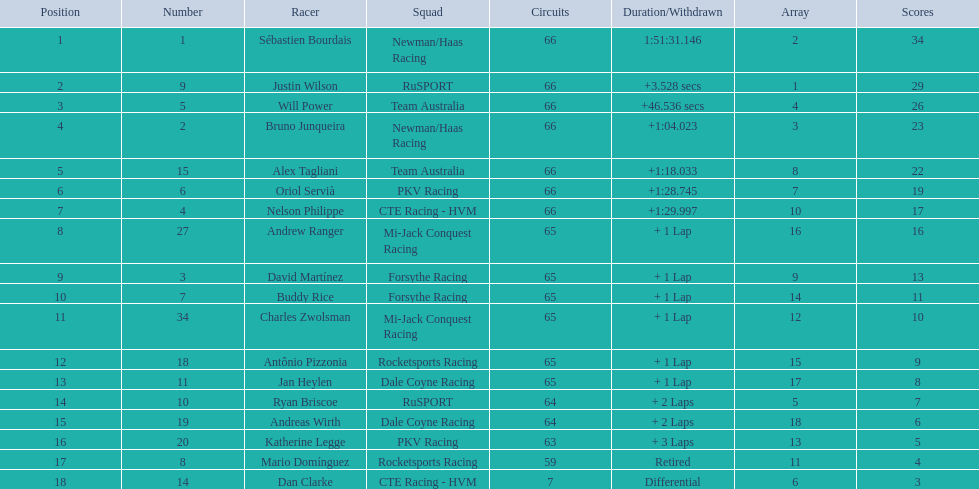Which people scored 29+ points? Sébastien Bourdais, Justin Wilson. Who scored higher? Sébastien Bourdais. 